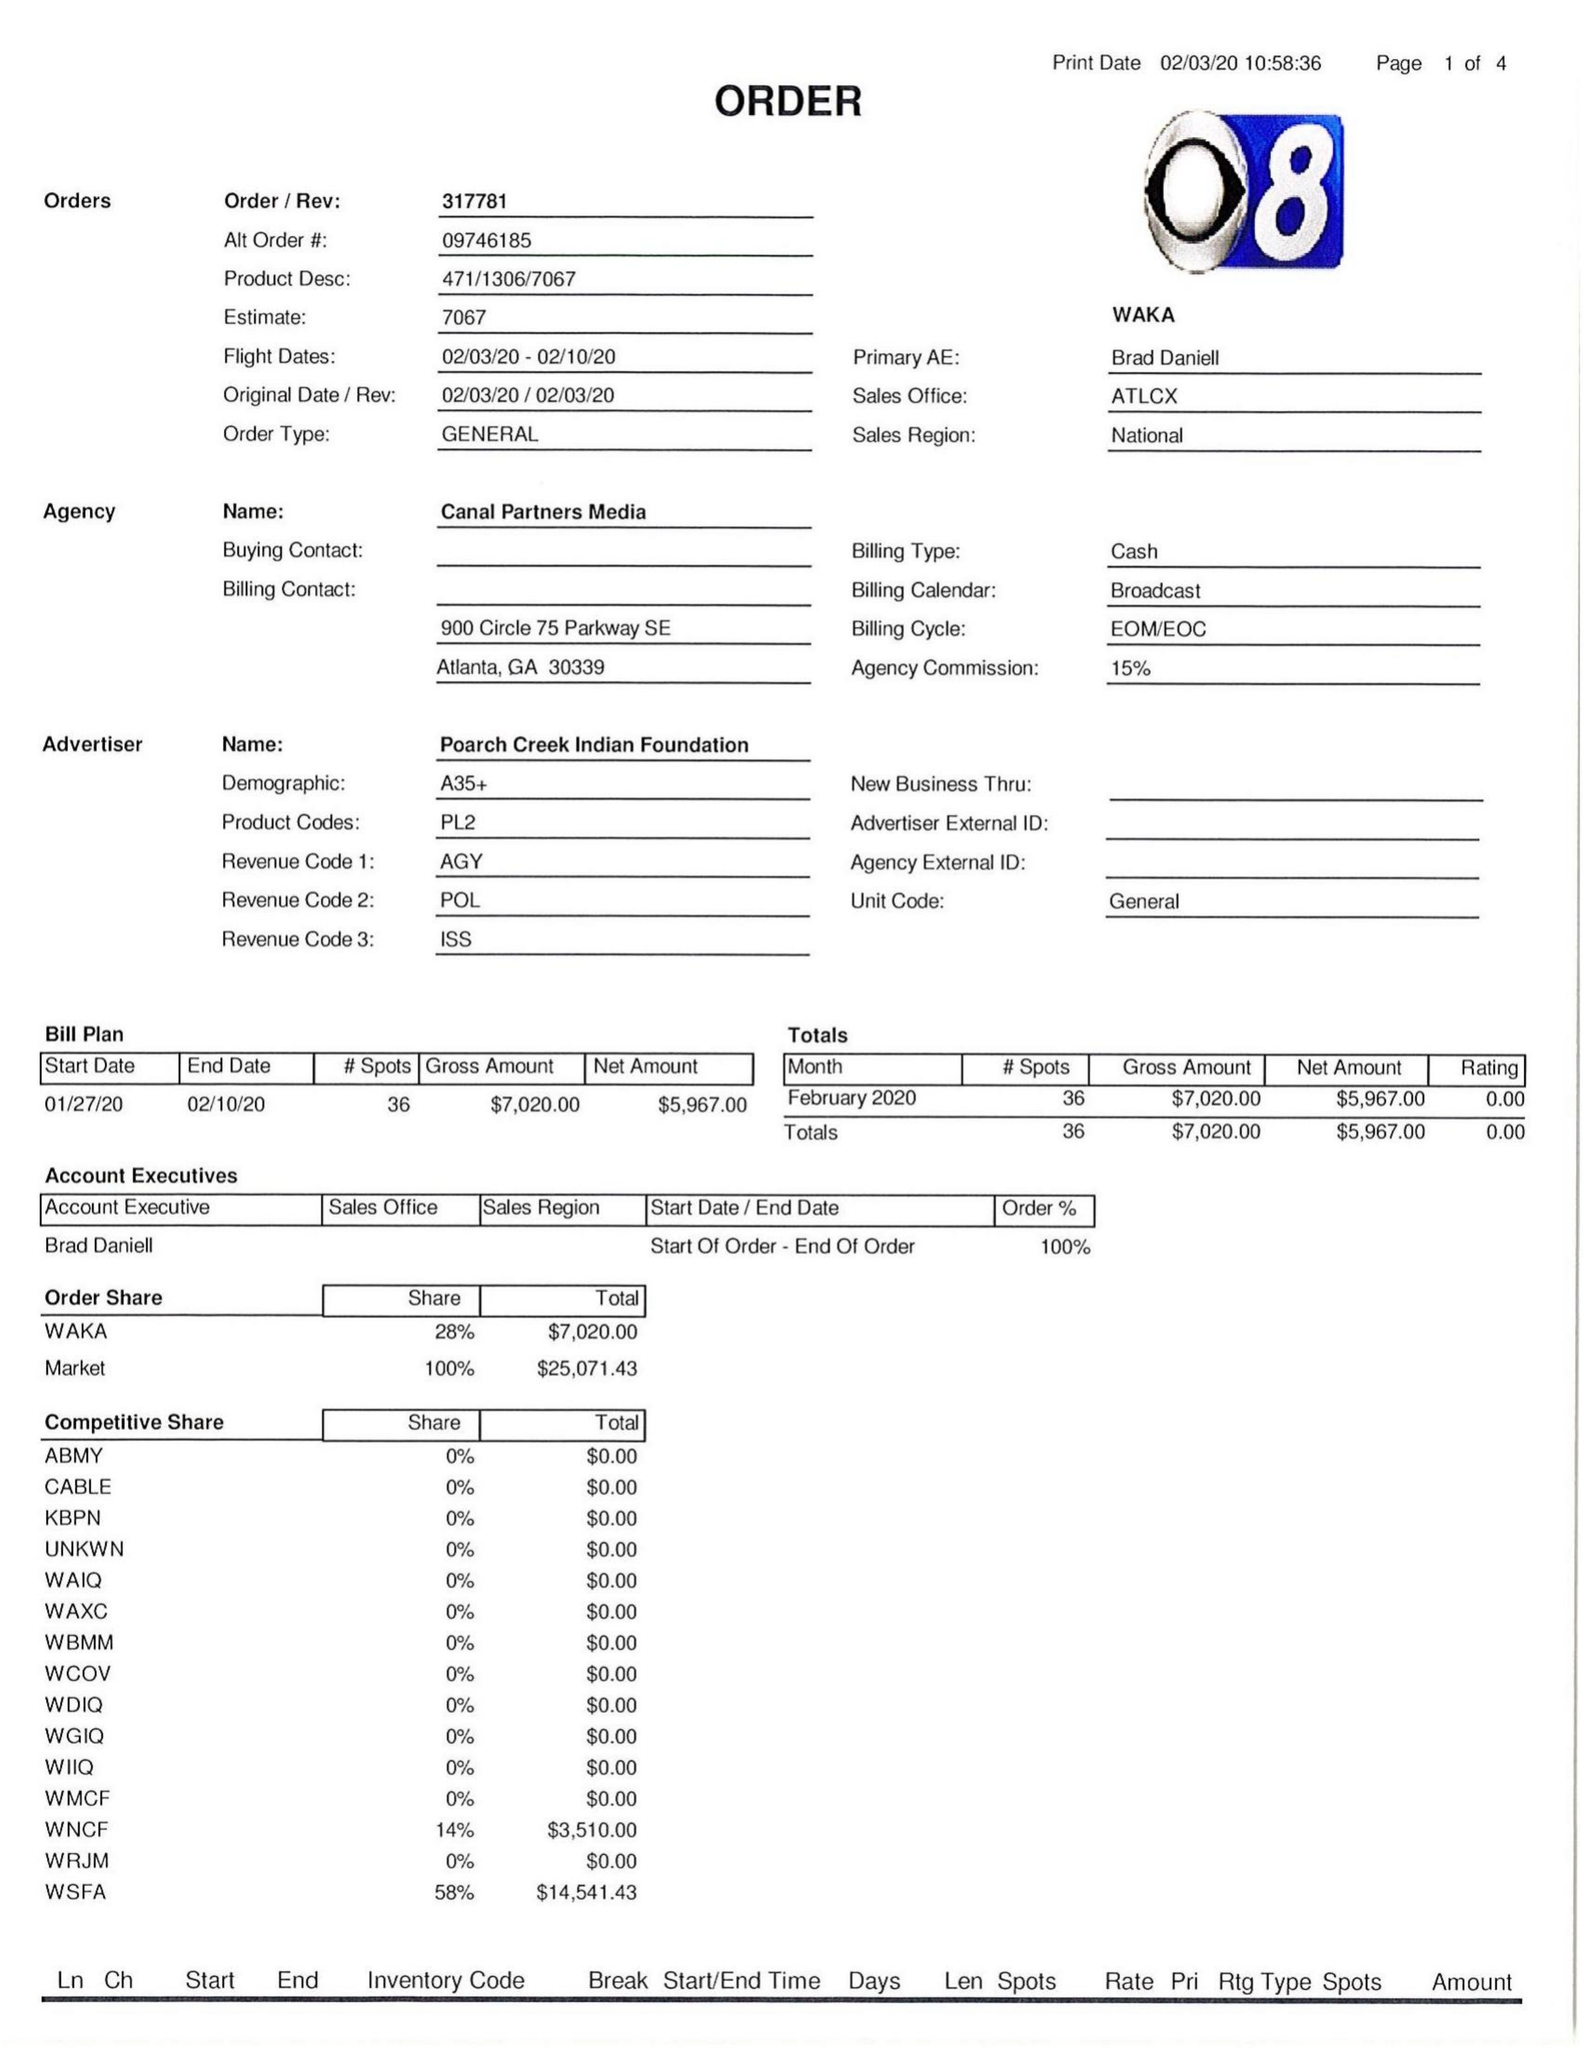What is the value for the advertiser?
Answer the question using a single word or phrase. POARCH CREEK INDIAN FOUNDATION 